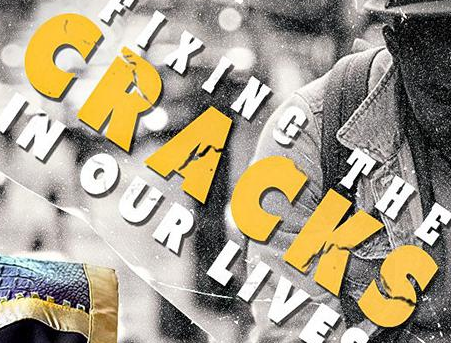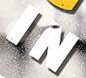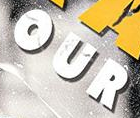What words are shown in these images in order, separated by a semicolon? CRACKS; IN; OUR 